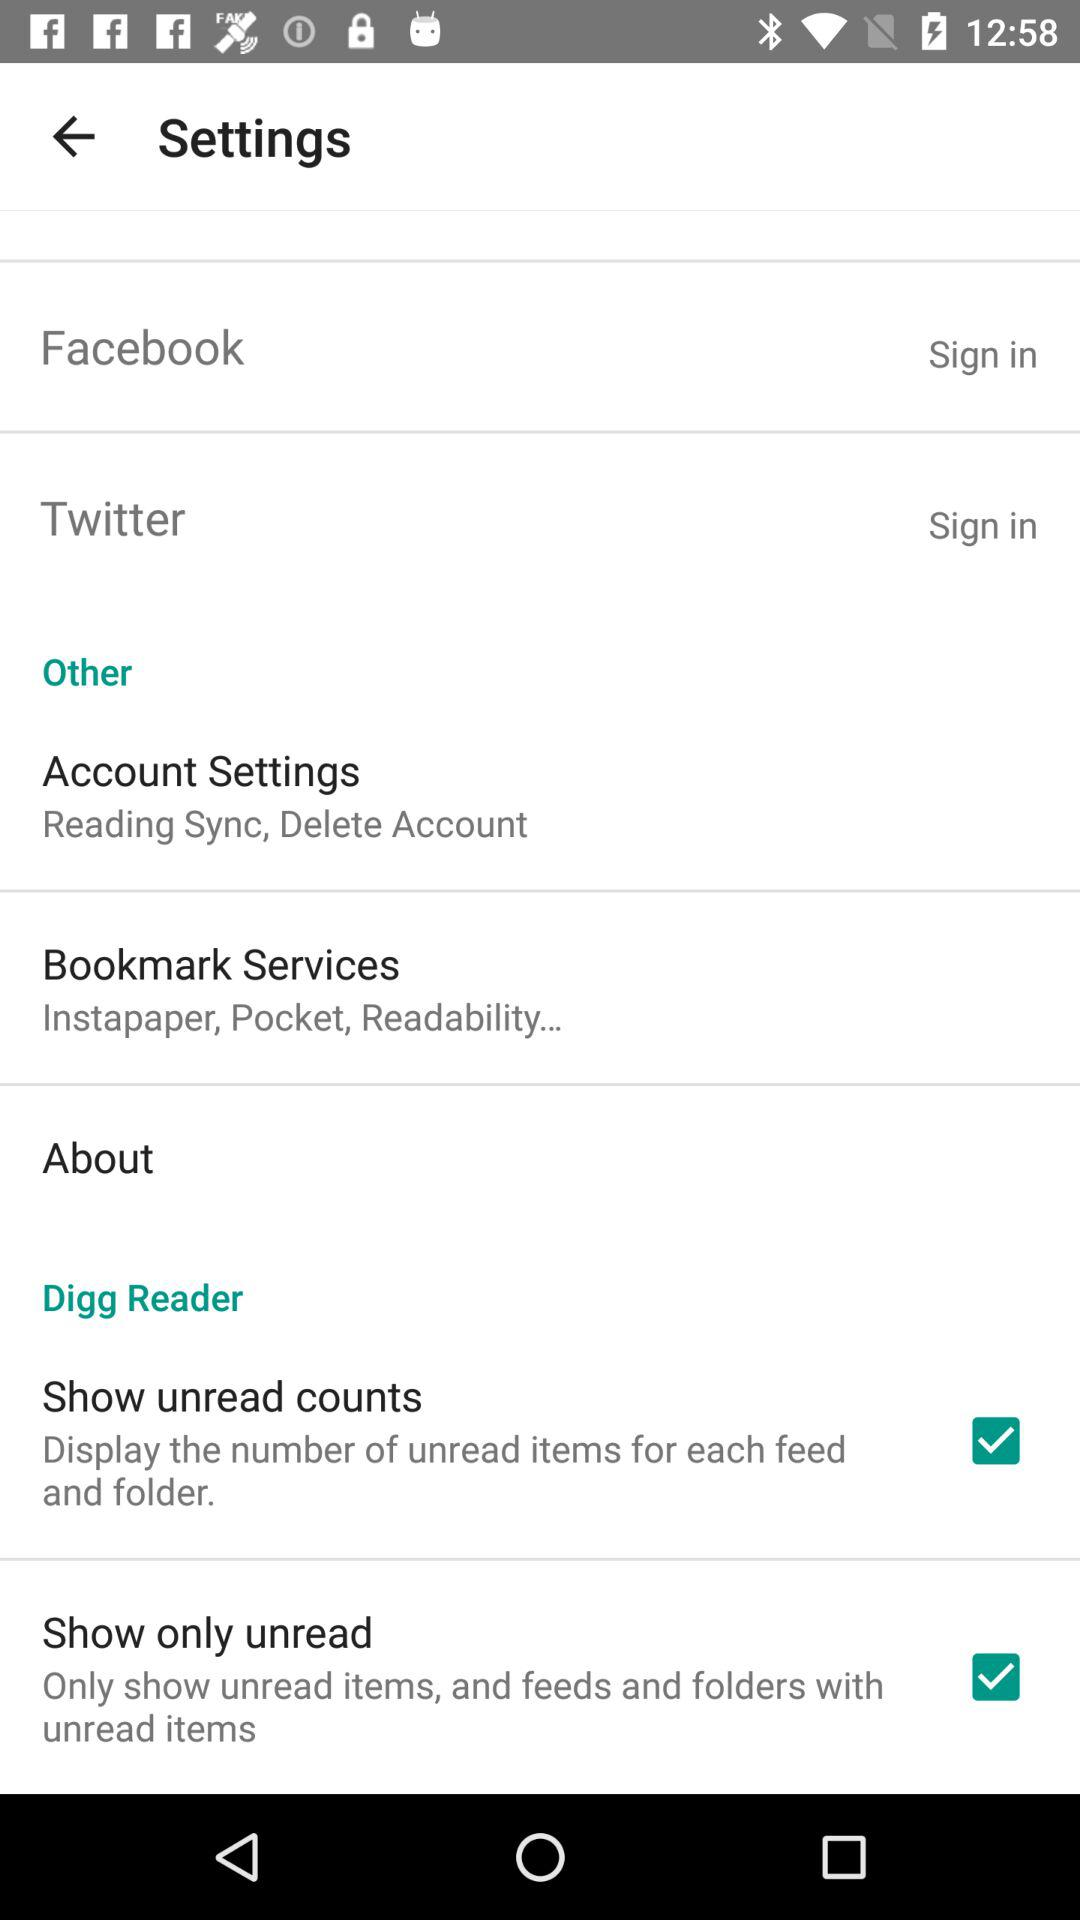What options are there in the account settings? The options in the account settings are "Reading Sync, Delete Account". 